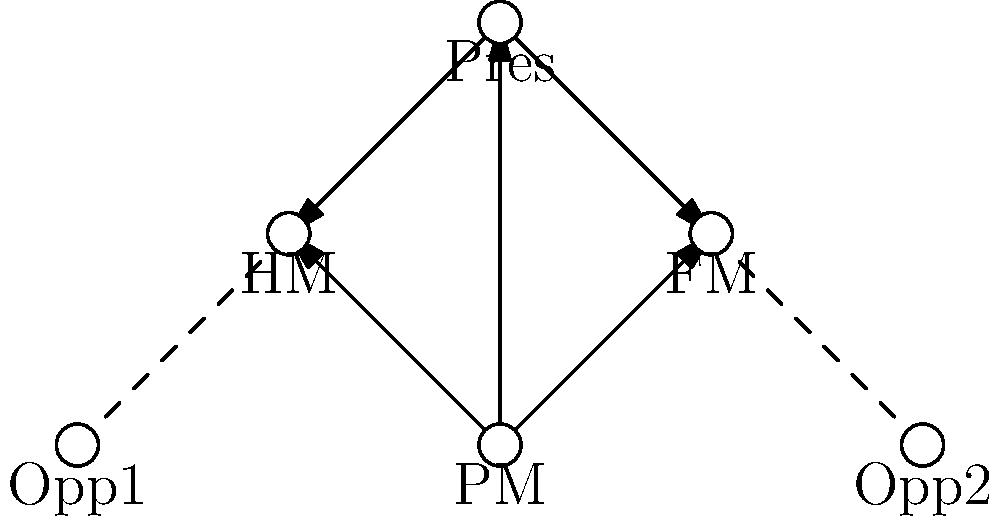In this network diagram representing the political power structure of a fictional country, which position holds the most direct connections and appears to be the central node of influence? To determine the most influential position in this political network, we need to analyze the connections and their nature:

1. Identify all positions:
   PM (Prime Minister), FM (Foreign Minister), HM (Home Minister), Pres (President), Opp1 (Opposition Leader 1), Opp2 (Opposition Leader 2)

2. Count direct connections for each position:
   PM: 3 outgoing arrows (to FM, HM, and Pres)
   FM: 1 incoming arrow (from PM), 1 incoming arrow (from Pres), 1 dashed line (from Opp2)
   HM: 1 incoming arrow (from PM), 1 incoming arrow (from Pres), 1 dashed line (from Opp1)
   Pres: 1 incoming arrow (from PM), 2 outgoing arrows (to FM and HM)
   Opp1: 1 dashed line (to HM)
   Opp2: 1 dashed line (to FM)

3. Analyze the nature of connections:
   - Solid arrows represent strong, direct influence
   - Dashed lines represent weaker or indirect connections

4. Evaluate centrality:
   The PM has the most outgoing solid arrows, indicating direct influence over other key positions.

5. Consider the hierarchy:
   The PM appears to be at the top of the hierarchy, with direct influence over both ministers and the President.

Based on this analysis, the Prime Minister (PM) holds the most direct connections and appears to be the central node of influence in this political network.
Answer: Prime Minister (PM) 